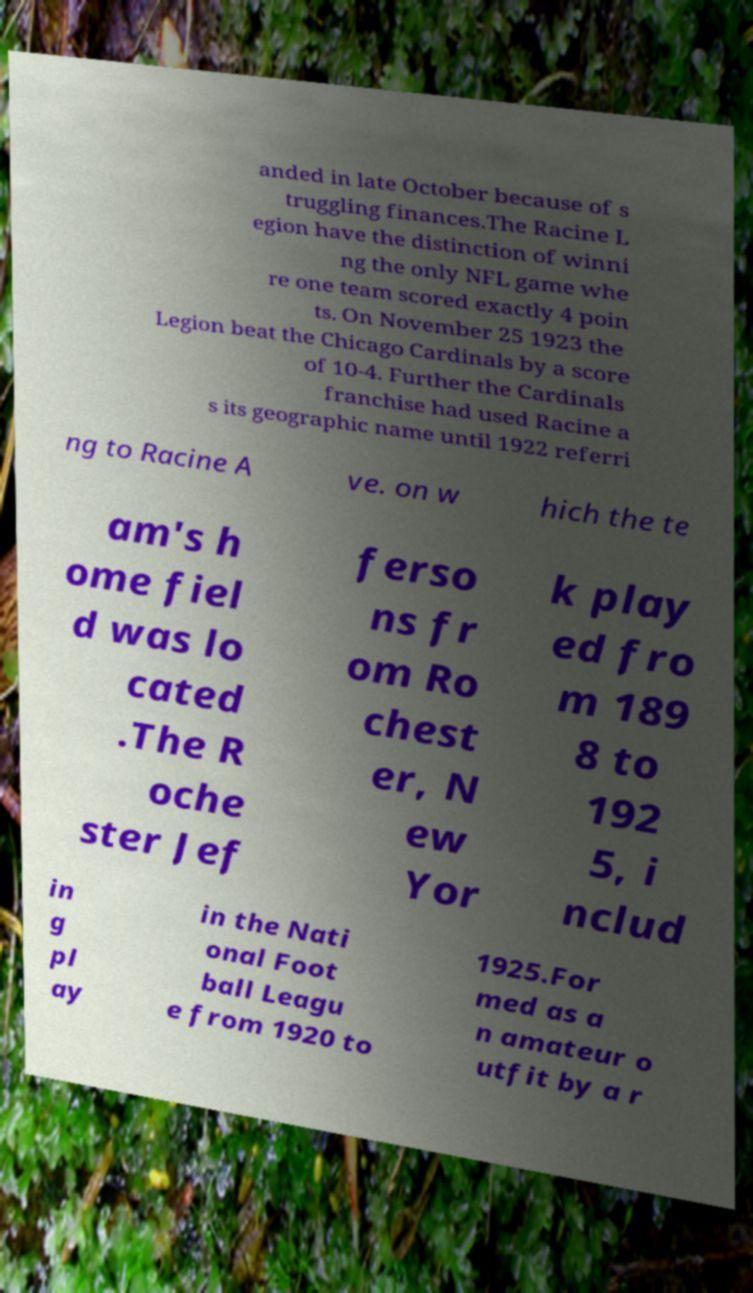Can you accurately transcribe the text from the provided image for me? anded in late October because of s truggling finances.The Racine L egion have the distinction of winni ng the only NFL game whe re one team scored exactly 4 poin ts. On November 25 1923 the Legion beat the Chicago Cardinals by a score of 10-4. Further the Cardinals franchise had used Racine a s its geographic name until 1922 referri ng to Racine A ve. on w hich the te am's h ome fiel d was lo cated .The R oche ster Jef ferso ns fr om Ro chest er, N ew Yor k play ed fro m 189 8 to 192 5, i nclud in g pl ay in the Nati onal Foot ball Leagu e from 1920 to 1925.For med as a n amateur o utfit by a r 